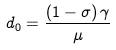Convert formula to latex. <formula><loc_0><loc_0><loc_500><loc_500>d _ { 0 } = \frac { \left ( 1 - \sigma \right ) \gamma } { \mu }</formula> 